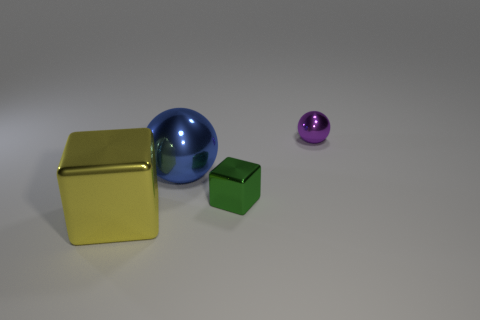Subtract 2 cubes. How many cubes are left? 0 Subtract all gray spheres. Subtract all purple cylinders. How many spheres are left? 2 Subtract all yellow blocks. How many green spheres are left? 0 Subtract all big metal objects. Subtract all large blue shiny objects. How many objects are left? 1 Add 3 small metal things. How many small metal things are left? 5 Add 4 large metallic cubes. How many large metallic cubes exist? 5 Add 3 small metal things. How many objects exist? 7 Subtract 1 yellow cubes. How many objects are left? 3 